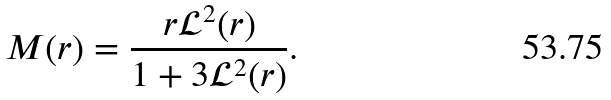Convert formula to latex. <formula><loc_0><loc_0><loc_500><loc_500>M ( r ) = \frac { r \mathcal { L } ^ { 2 } ( r ) } { 1 + 3 \mathcal { L } ^ { 2 } ( r ) } .</formula> 